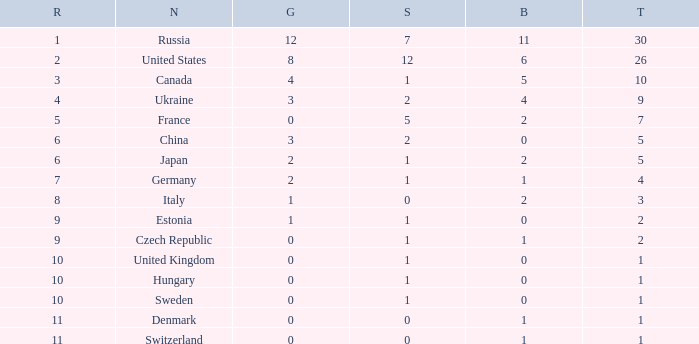How many silvers have a Nation of hungary, and a Rank larger than 10? 0.0. 